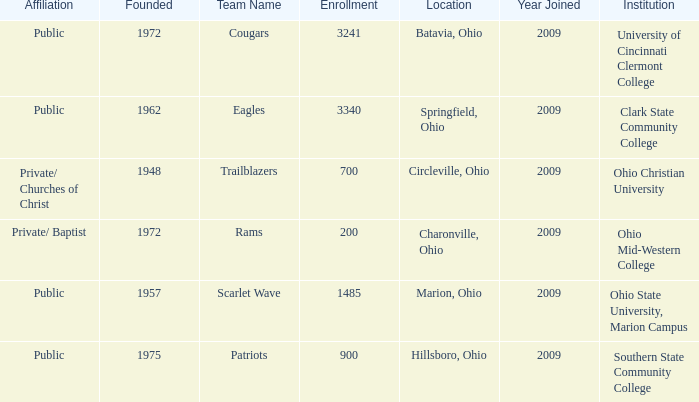What was the location for the team name of patriots? Hillsboro, Ohio. 